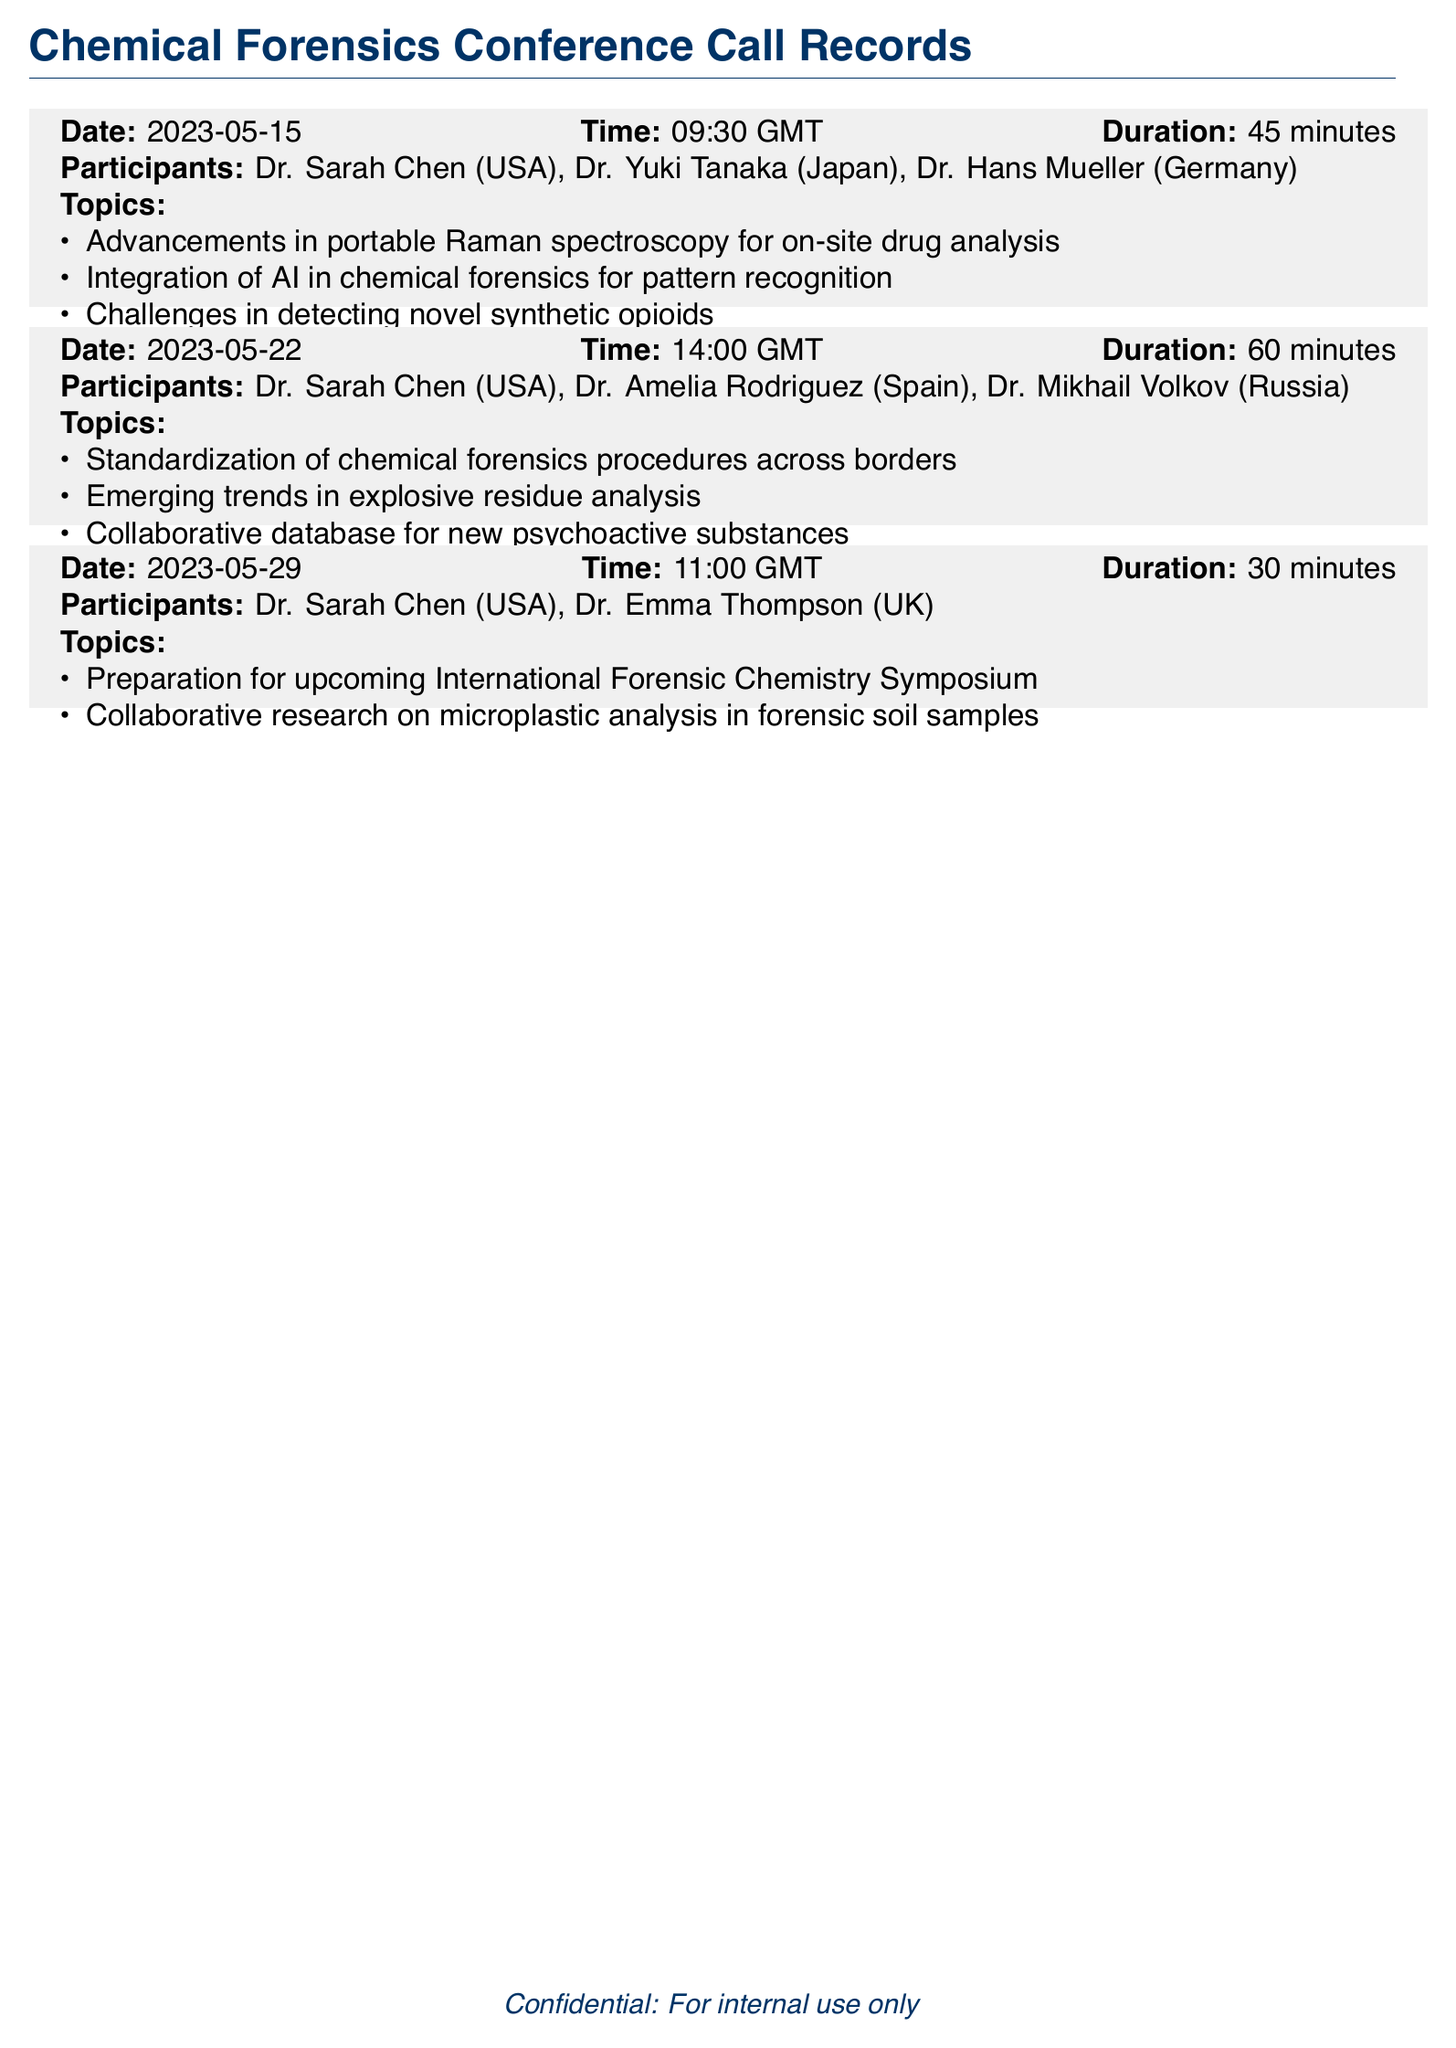What is the date of the first conference call? The first conference call is recorded on May 15, 2023.
Answer: May 15, 2023 Who participated in the call on May 22, 2023? The participants of the May 22 call are listed as Dr. Sarah Chen, Dr. Amelia Rodriguez, and Dr. Mikhail Volkov.
Answer: Dr. Sarah Chen, Dr. Amelia Rodriguez, Dr. Mikhail Volkov How many minutes did the call on May 29, 2023 last? The duration of the call on May 29 is specifically noted as 30 minutes.
Answer: 30 minutes What topic was discussed regarding AI in chemical forensics? The topic mentioned is the integration of AI in chemical forensics for pattern recognition.
Answer: Integration of AI in chemical forensics for pattern recognition What is the duration of the second conference call? The second conference call lasted for 60 minutes, as indicated in the document.
Answer: 60 minutes Which country is Dr. Yuki Tanaka from? Dr. Yuki Tanaka is noted as being from Japan in the records.
Answer: Japan What is one challenge mentioned in the calls related to synthetic opioids? One of the challenges discussed is in detecting novel synthetic opioids.
Answer: Detecting novel synthetic opioids How many participants were present in the call on May 29, 2023? The May 29 call had 2 participants as indicated in the document.
Answer: 2 participants 